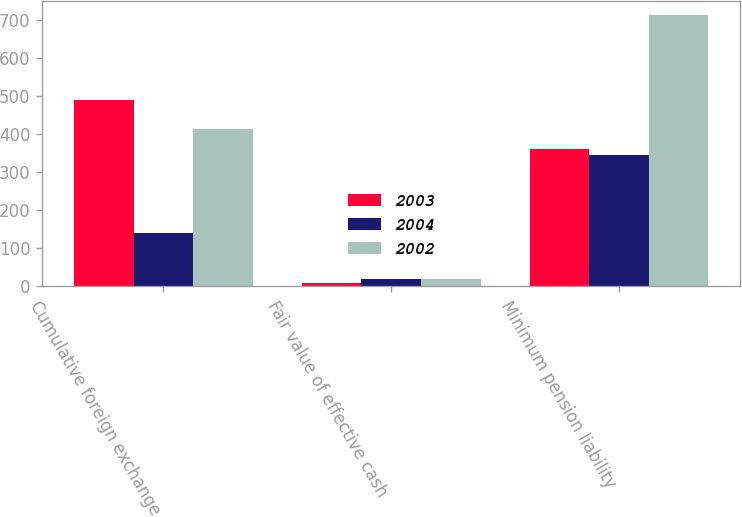Convert chart. <chart><loc_0><loc_0><loc_500><loc_500><stacked_bar_chart><ecel><fcel>Cumulative foreign exchange<fcel>Fair value of effective cash<fcel>Minimum pension liability<nl><fcel>2003<fcel>489<fcel>8<fcel>359<nl><fcel>2004<fcel>138<fcel>17<fcel>344<nl><fcel>2002<fcel>413<fcel>17<fcel>713<nl></chart> 